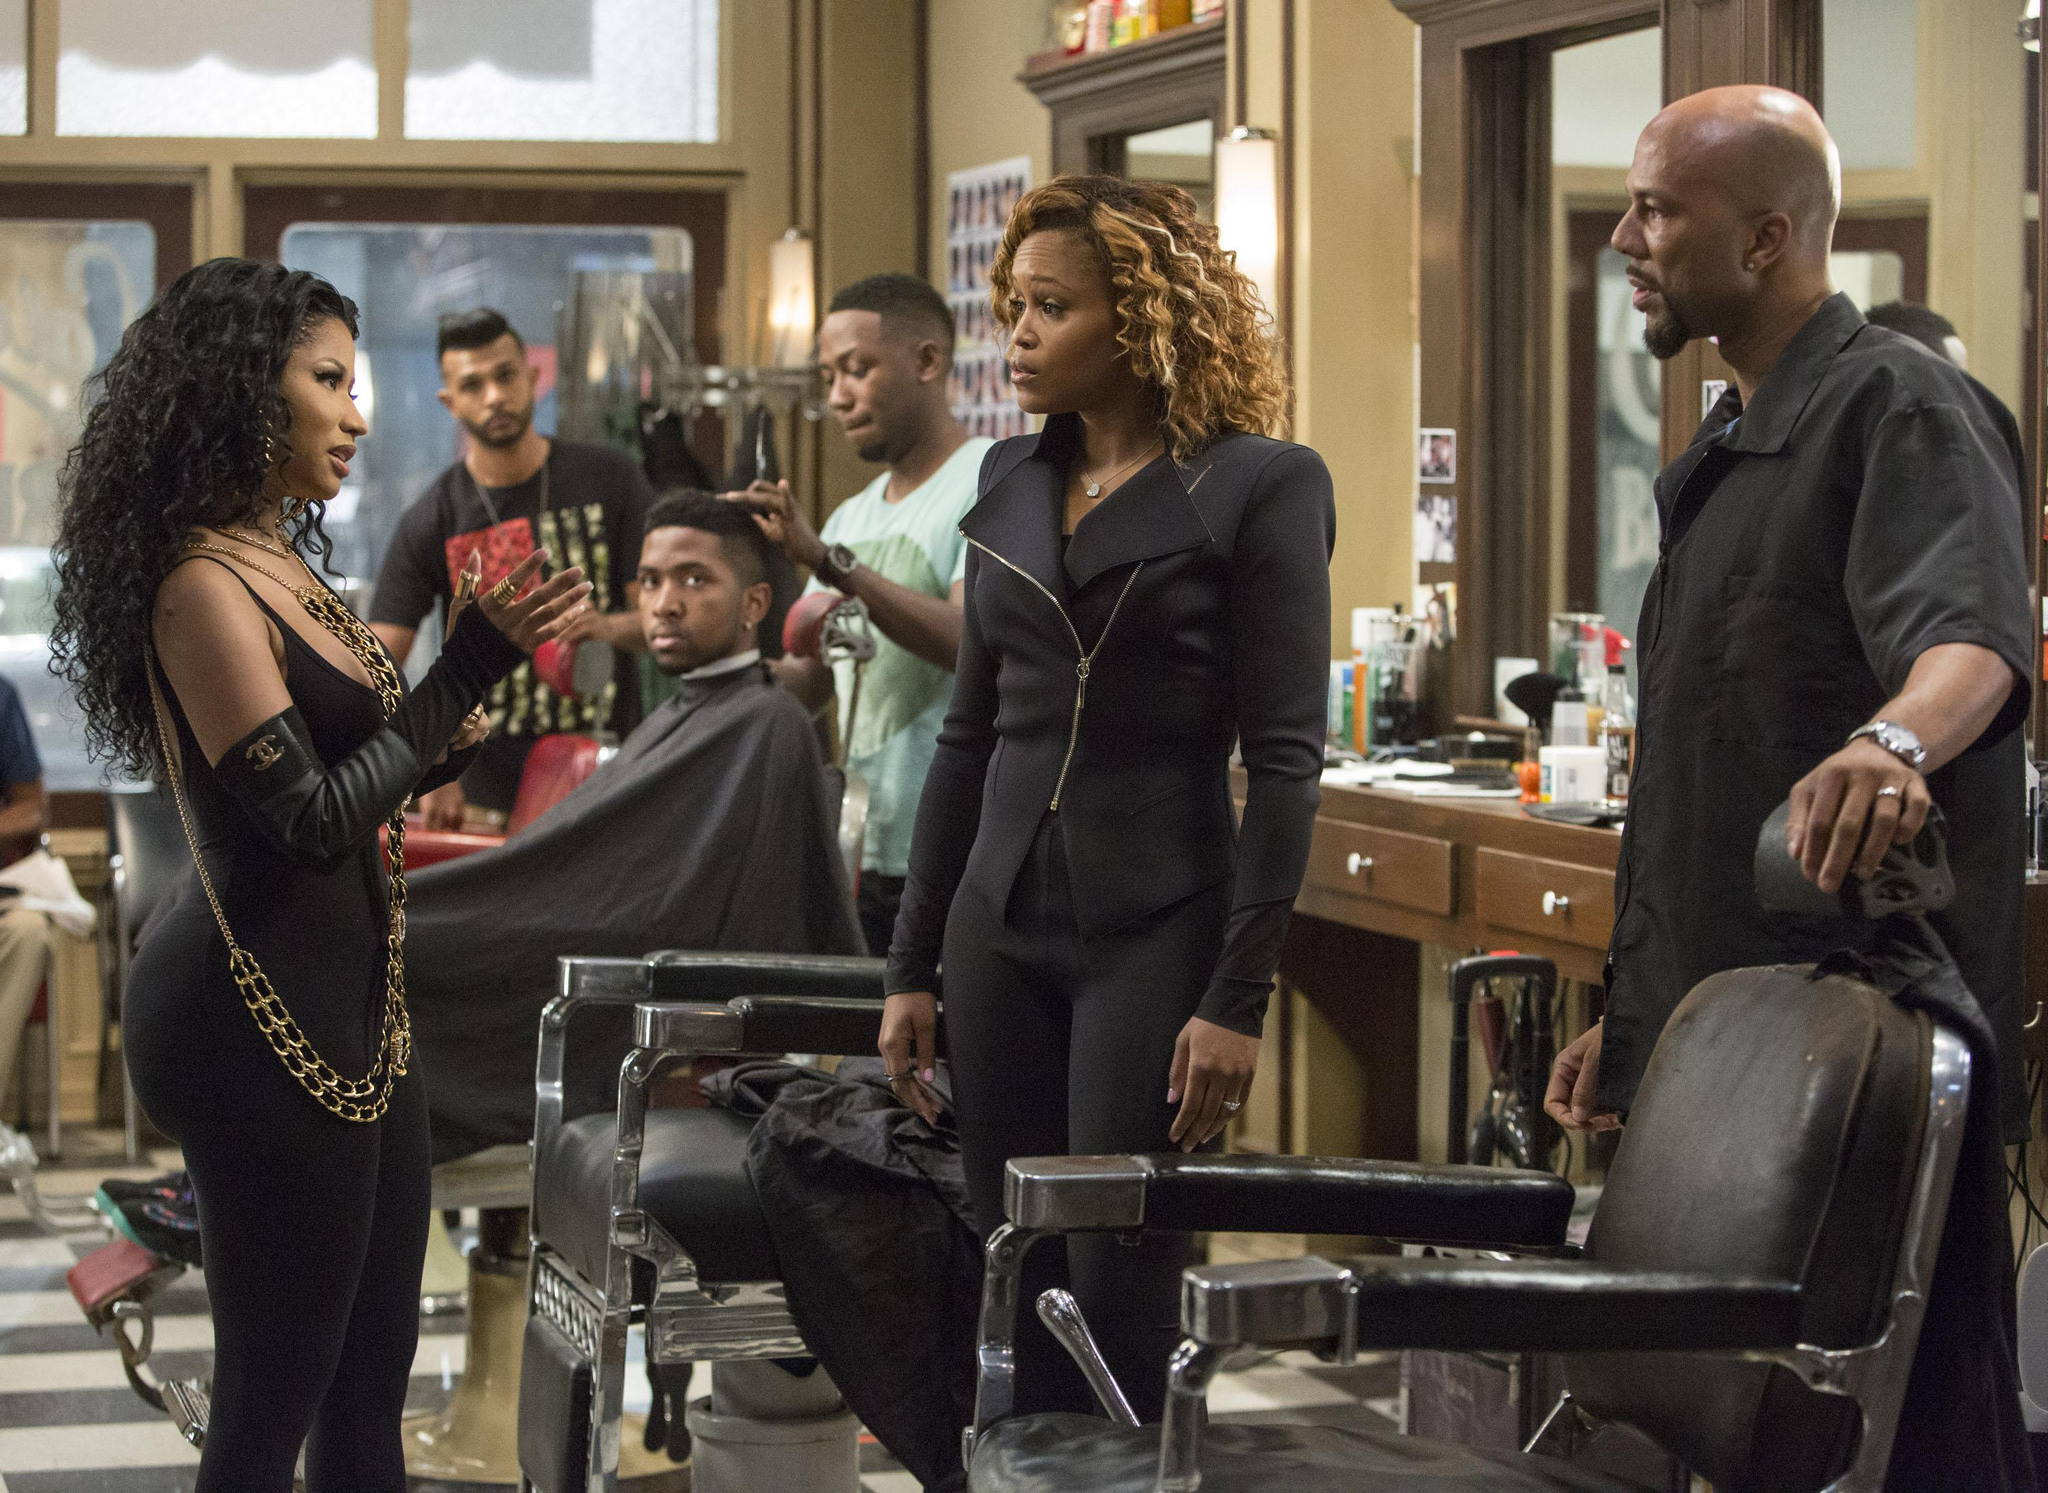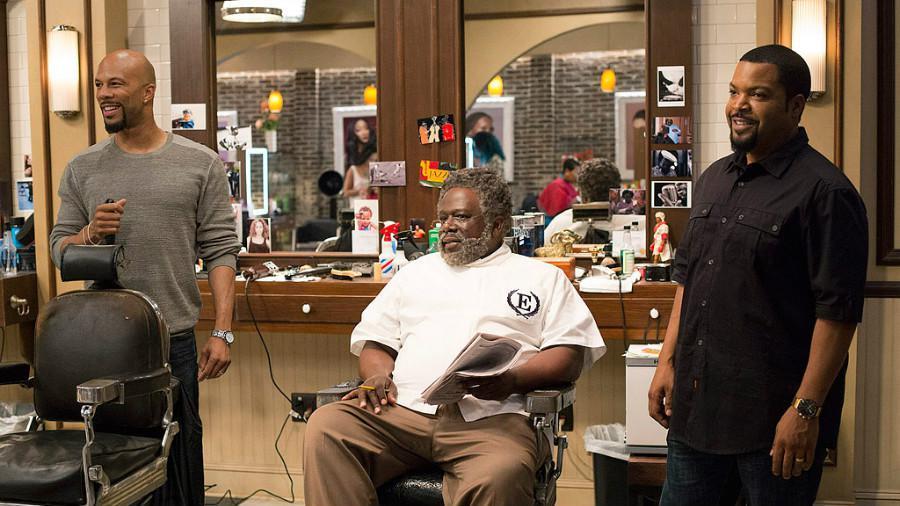The first image is the image on the left, the second image is the image on the right. Considering the images on both sides, is "The woman in the image on the right is standing in front of a brick wall." valid? Answer yes or no. No. The first image is the image on the left, the second image is the image on the right. Analyze the images presented: Is the assertion "An image includes a black man with grizzled gray hair and beard, wearing a white top and khaki pants, and sitting in a barber chair." valid? Answer yes or no. Yes. 